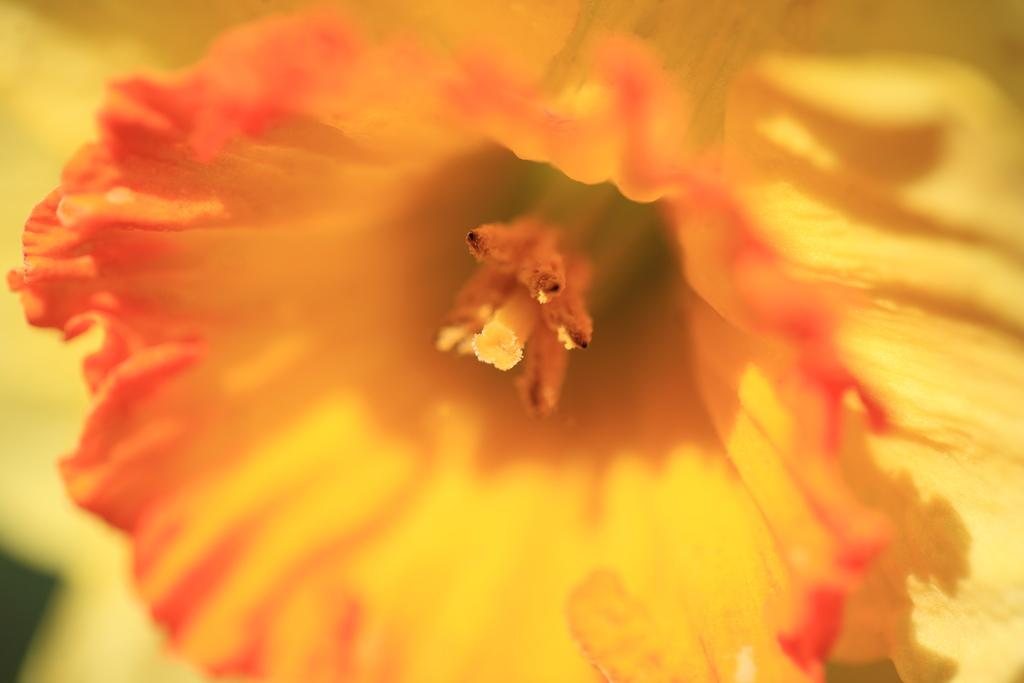What is the main subject of the image? There is a flower in the image. Can you describe the colors of the flower? The flower has orange and yellow colors. What is the chance of a creature appearing in the image? There is no mention of a creature in the image, so it is not possible to determine the chance of one appearing. 